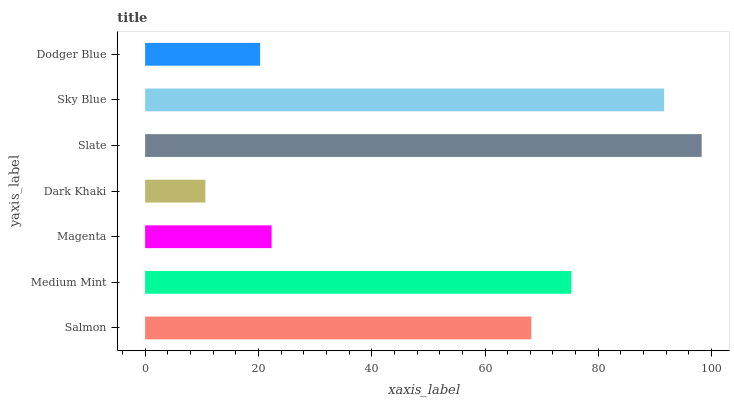Is Dark Khaki the minimum?
Answer yes or no. Yes. Is Slate the maximum?
Answer yes or no. Yes. Is Medium Mint the minimum?
Answer yes or no. No. Is Medium Mint the maximum?
Answer yes or no. No. Is Medium Mint greater than Salmon?
Answer yes or no. Yes. Is Salmon less than Medium Mint?
Answer yes or no. Yes. Is Salmon greater than Medium Mint?
Answer yes or no. No. Is Medium Mint less than Salmon?
Answer yes or no. No. Is Salmon the high median?
Answer yes or no. Yes. Is Salmon the low median?
Answer yes or no. Yes. Is Dark Khaki the high median?
Answer yes or no. No. Is Magenta the low median?
Answer yes or no. No. 